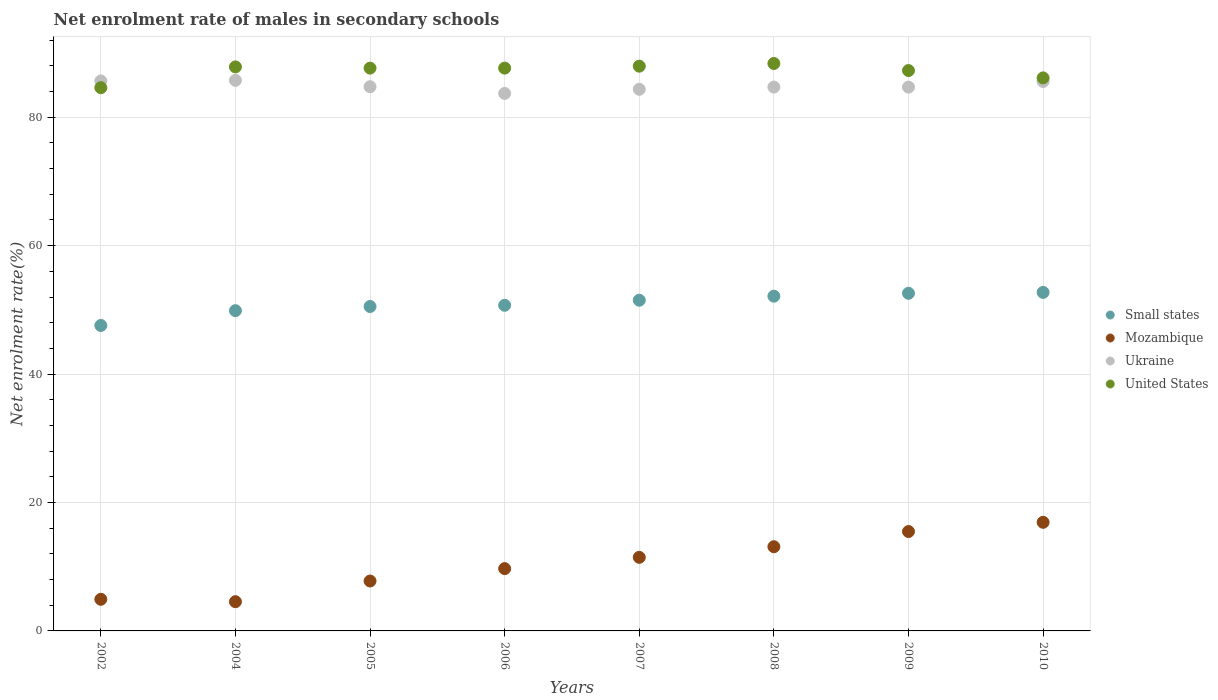How many different coloured dotlines are there?
Give a very brief answer. 4. What is the net enrolment rate of males in secondary schools in Small states in 2004?
Give a very brief answer. 49.88. Across all years, what is the maximum net enrolment rate of males in secondary schools in Mozambique?
Offer a very short reply. 16.92. Across all years, what is the minimum net enrolment rate of males in secondary schools in Mozambique?
Make the answer very short. 4.55. In which year was the net enrolment rate of males in secondary schools in Ukraine minimum?
Give a very brief answer. 2006. What is the total net enrolment rate of males in secondary schools in Ukraine in the graph?
Keep it short and to the point. 679.21. What is the difference between the net enrolment rate of males in secondary schools in Mozambique in 2006 and that in 2008?
Offer a very short reply. -3.41. What is the difference between the net enrolment rate of males in secondary schools in Mozambique in 2002 and the net enrolment rate of males in secondary schools in Ukraine in 2010?
Ensure brevity in your answer.  -80.65. What is the average net enrolment rate of males in secondary schools in United States per year?
Give a very brief answer. 87.19. In the year 2002, what is the difference between the net enrolment rate of males in secondary schools in Ukraine and net enrolment rate of males in secondary schools in Small states?
Offer a terse response. 38.09. What is the ratio of the net enrolment rate of males in secondary schools in Ukraine in 2005 to that in 2006?
Keep it short and to the point. 1.01. What is the difference between the highest and the second highest net enrolment rate of males in secondary schools in Ukraine?
Offer a very short reply. 0.09. What is the difference between the highest and the lowest net enrolment rate of males in secondary schools in Small states?
Give a very brief answer. 5.15. Is the sum of the net enrolment rate of males in secondary schools in United States in 2006 and 2009 greater than the maximum net enrolment rate of males in secondary schools in Mozambique across all years?
Provide a short and direct response. Yes. Is it the case that in every year, the sum of the net enrolment rate of males in secondary schools in Mozambique and net enrolment rate of males in secondary schools in Small states  is greater than the sum of net enrolment rate of males in secondary schools in United States and net enrolment rate of males in secondary schools in Ukraine?
Offer a very short reply. No. Is it the case that in every year, the sum of the net enrolment rate of males in secondary schools in United States and net enrolment rate of males in secondary schools in Ukraine  is greater than the net enrolment rate of males in secondary schools in Mozambique?
Ensure brevity in your answer.  Yes. Is the net enrolment rate of males in secondary schools in United States strictly greater than the net enrolment rate of males in secondary schools in Small states over the years?
Keep it short and to the point. Yes. Is the net enrolment rate of males in secondary schools in Small states strictly less than the net enrolment rate of males in secondary schools in Mozambique over the years?
Provide a short and direct response. No. Does the graph contain any zero values?
Ensure brevity in your answer.  No. Does the graph contain grids?
Your response must be concise. Yes. Where does the legend appear in the graph?
Your answer should be very brief. Center right. How many legend labels are there?
Make the answer very short. 4. What is the title of the graph?
Give a very brief answer. Net enrolment rate of males in secondary schools. What is the label or title of the X-axis?
Your answer should be very brief. Years. What is the label or title of the Y-axis?
Give a very brief answer. Net enrolment rate(%). What is the Net enrolment rate(%) in Small states in 2002?
Provide a short and direct response. 47.57. What is the Net enrolment rate(%) in Mozambique in 2002?
Provide a short and direct response. 4.92. What is the Net enrolment rate(%) of Ukraine in 2002?
Your answer should be compact. 85.66. What is the Net enrolment rate(%) in United States in 2002?
Offer a terse response. 84.61. What is the Net enrolment rate(%) in Small states in 2004?
Offer a terse response. 49.88. What is the Net enrolment rate(%) of Mozambique in 2004?
Your answer should be compact. 4.55. What is the Net enrolment rate(%) in Ukraine in 2004?
Provide a succinct answer. 85.75. What is the Net enrolment rate(%) of United States in 2004?
Ensure brevity in your answer.  87.84. What is the Net enrolment rate(%) in Small states in 2005?
Offer a very short reply. 50.53. What is the Net enrolment rate(%) of Mozambique in 2005?
Provide a succinct answer. 7.77. What is the Net enrolment rate(%) of Ukraine in 2005?
Provide a short and direct response. 84.76. What is the Net enrolment rate(%) of United States in 2005?
Your response must be concise. 87.65. What is the Net enrolment rate(%) of Small states in 2006?
Offer a terse response. 50.71. What is the Net enrolment rate(%) in Mozambique in 2006?
Your answer should be very brief. 9.7. What is the Net enrolment rate(%) of Ukraine in 2006?
Your response must be concise. 83.71. What is the Net enrolment rate(%) in United States in 2006?
Give a very brief answer. 87.65. What is the Net enrolment rate(%) of Small states in 2007?
Your answer should be compact. 51.5. What is the Net enrolment rate(%) in Mozambique in 2007?
Keep it short and to the point. 11.46. What is the Net enrolment rate(%) of Ukraine in 2007?
Keep it short and to the point. 84.36. What is the Net enrolment rate(%) in United States in 2007?
Your answer should be very brief. 87.96. What is the Net enrolment rate(%) in Small states in 2008?
Ensure brevity in your answer.  52.13. What is the Net enrolment rate(%) in Mozambique in 2008?
Your answer should be compact. 13.11. What is the Net enrolment rate(%) in Ukraine in 2008?
Give a very brief answer. 84.7. What is the Net enrolment rate(%) in United States in 2008?
Give a very brief answer. 88.38. What is the Net enrolment rate(%) of Small states in 2009?
Offer a very short reply. 52.59. What is the Net enrolment rate(%) in Mozambique in 2009?
Offer a very short reply. 15.48. What is the Net enrolment rate(%) in Ukraine in 2009?
Your answer should be very brief. 84.7. What is the Net enrolment rate(%) in United States in 2009?
Make the answer very short. 87.27. What is the Net enrolment rate(%) in Small states in 2010?
Offer a very short reply. 52.72. What is the Net enrolment rate(%) in Mozambique in 2010?
Your answer should be compact. 16.92. What is the Net enrolment rate(%) of Ukraine in 2010?
Make the answer very short. 85.57. What is the Net enrolment rate(%) in United States in 2010?
Keep it short and to the point. 86.13. Across all years, what is the maximum Net enrolment rate(%) in Small states?
Your response must be concise. 52.72. Across all years, what is the maximum Net enrolment rate(%) of Mozambique?
Ensure brevity in your answer.  16.92. Across all years, what is the maximum Net enrolment rate(%) of Ukraine?
Your answer should be very brief. 85.75. Across all years, what is the maximum Net enrolment rate(%) of United States?
Your answer should be compact. 88.38. Across all years, what is the minimum Net enrolment rate(%) of Small states?
Provide a short and direct response. 47.57. Across all years, what is the minimum Net enrolment rate(%) in Mozambique?
Provide a short and direct response. 4.55. Across all years, what is the minimum Net enrolment rate(%) in Ukraine?
Offer a very short reply. 83.71. Across all years, what is the minimum Net enrolment rate(%) in United States?
Give a very brief answer. 84.61. What is the total Net enrolment rate(%) of Small states in the graph?
Offer a terse response. 407.64. What is the total Net enrolment rate(%) of Mozambique in the graph?
Keep it short and to the point. 83.92. What is the total Net enrolment rate(%) of Ukraine in the graph?
Offer a terse response. 679.21. What is the total Net enrolment rate(%) in United States in the graph?
Make the answer very short. 697.5. What is the difference between the Net enrolment rate(%) of Small states in 2002 and that in 2004?
Keep it short and to the point. -2.31. What is the difference between the Net enrolment rate(%) of Mozambique in 2002 and that in 2004?
Your answer should be very brief. 0.37. What is the difference between the Net enrolment rate(%) in Ukraine in 2002 and that in 2004?
Your answer should be compact. -0.09. What is the difference between the Net enrolment rate(%) in United States in 2002 and that in 2004?
Offer a terse response. -3.24. What is the difference between the Net enrolment rate(%) in Small states in 2002 and that in 2005?
Your response must be concise. -2.96. What is the difference between the Net enrolment rate(%) in Mozambique in 2002 and that in 2005?
Provide a succinct answer. -2.85. What is the difference between the Net enrolment rate(%) of Ukraine in 2002 and that in 2005?
Your answer should be compact. 0.9. What is the difference between the Net enrolment rate(%) in United States in 2002 and that in 2005?
Your response must be concise. -3.04. What is the difference between the Net enrolment rate(%) in Small states in 2002 and that in 2006?
Offer a terse response. -3.14. What is the difference between the Net enrolment rate(%) of Mozambique in 2002 and that in 2006?
Ensure brevity in your answer.  -4.78. What is the difference between the Net enrolment rate(%) of Ukraine in 2002 and that in 2006?
Offer a very short reply. 1.95. What is the difference between the Net enrolment rate(%) of United States in 2002 and that in 2006?
Make the answer very short. -3.05. What is the difference between the Net enrolment rate(%) of Small states in 2002 and that in 2007?
Provide a succinct answer. -3.93. What is the difference between the Net enrolment rate(%) of Mozambique in 2002 and that in 2007?
Offer a terse response. -6.54. What is the difference between the Net enrolment rate(%) in Ukraine in 2002 and that in 2007?
Offer a terse response. 1.3. What is the difference between the Net enrolment rate(%) in United States in 2002 and that in 2007?
Your answer should be compact. -3.35. What is the difference between the Net enrolment rate(%) in Small states in 2002 and that in 2008?
Ensure brevity in your answer.  -4.56. What is the difference between the Net enrolment rate(%) of Mozambique in 2002 and that in 2008?
Make the answer very short. -8.19. What is the difference between the Net enrolment rate(%) in Ukraine in 2002 and that in 2008?
Make the answer very short. 0.96. What is the difference between the Net enrolment rate(%) in United States in 2002 and that in 2008?
Keep it short and to the point. -3.77. What is the difference between the Net enrolment rate(%) in Small states in 2002 and that in 2009?
Offer a very short reply. -5.02. What is the difference between the Net enrolment rate(%) in Mozambique in 2002 and that in 2009?
Keep it short and to the point. -10.55. What is the difference between the Net enrolment rate(%) of Ukraine in 2002 and that in 2009?
Offer a very short reply. 0.96. What is the difference between the Net enrolment rate(%) of United States in 2002 and that in 2009?
Your response must be concise. -2.67. What is the difference between the Net enrolment rate(%) in Small states in 2002 and that in 2010?
Ensure brevity in your answer.  -5.15. What is the difference between the Net enrolment rate(%) of Mozambique in 2002 and that in 2010?
Provide a short and direct response. -11.99. What is the difference between the Net enrolment rate(%) in Ukraine in 2002 and that in 2010?
Your response must be concise. 0.09. What is the difference between the Net enrolment rate(%) of United States in 2002 and that in 2010?
Keep it short and to the point. -1.53. What is the difference between the Net enrolment rate(%) in Small states in 2004 and that in 2005?
Give a very brief answer. -0.65. What is the difference between the Net enrolment rate(%) in Mozambique in 2004 and that in 2005?
Give a very brief answer. -3.22. What is the difference between the Net enrolment rate(%) in United States in 2004 and that in 2005?
Offer a terse response. 0.19. What is the difference between the Net enrolment rate(%) of Small states in 2004 and that in 2006?
Your response must be concise. -0.83. What is the difference between the Net enrolment rate(%) of Mozambique in 2004 and that in 2006?
Your response must be concise. -5.15. What is the difference between the Net enrolment rate(%) of Ukraine in 2004 and that in 2006?
Offer a very short reply. 2.04. What is the difference between the Net enrolment rate(%) in United States in 2004 and that in 2006?
Give a very brief answer. 0.19. What is the difference between the Net enrolment rate(%) in Small states in 2004 and that in 2007?
Make the answer very short. -1.62. What is the difference between the Net enrolment rate(%) of Mozambique in 2004 and that in 2007?
Keep it short and to the point. -6.91. What is the difference between the Net enrolment rate(%) in Ukraine in 2004 and that in 2007?
Provide a short and direct response. 1.4. What is the difference between the Net enrolment rate(%) in United States in 2004 and that in 2007?
Your answer should be very brief. -0.11. What is the difference between the Net enrolment rate(%) in Small states in 2004 and that in 2008?
Make the answer very short. -2.25. What is the difference between the Net enrolment rate(%) in Mozambique in 2004 and that in 2008?
Offer a terse response. -8.56. What is the difference between the Net enrolment rate(%) in Ukraine in 2004 and that in 2008?
Offer a terse response. 1.05. What is the difference between the Net enrolment rate(%) in United States in 2004 and that in 2008?
Provide a succinct answer. -0.53. What is the difference between the Net enrolment rate(%) in Small states in 2004 and that in 2009?
Ensure brevity in your answer.  -2.71. What is the difference between the Net enrolment rate(%) of Mozambique in 2004 and that in 2009?
Give a very brief answer. -10.93. What is the difference between the Net enrolment rate(%) of Ukraine in 2004 and that in 2009?
Provide a succinct answer. 1.06. What is the difference between the Net enrolment rate(%) of United States in 2004 and that in 2009?
Make the answer very short. 0.57. What is the difference between the Net enrolment rate(%) in Small states in 2004 and that in 2010?
Keep it short and to the point. -2.84. What is the difference between the Net enrolment rate(%) of Mozambique in 2004 and that in 2010?
Ensure brevity in your answer.  -12.36. What is the difference between the Net enrolment rate(%) in Ukraine in 2004 and that in 2010?
Your answer should be very brief. 0.18. What is the difference between the Net enrolment rate(%) of United States in 2004 and that in 2010?
Your answer should be very brief. 1.71. What is the difference between the Net enrolment rate(%) in Small states in 2005 and that in 2006?
Your response must be concise. -0.19. What is the difference between the Net enrolment rate(%) in Mozambique in 2005 and that in 2006?
Make the answer very short. -1.93. What is the difference between the Net enrolment rate(%) of Ukraine in 2005 and that in 2006?
Your answer should be very brief. 1.05. What is the difference between the Net enrolment rate(%) of United States in 2005 and that in 2006?
Your answer should be very brief. -0. What is the difference between the Net enrolment rate(%) in Small states in 2005 and that in 2007?
Keep it short and to the point. -0.98. What is the difference between the Net enrolment rate(%) in Mozambique in 2005 and that in 2007?
Give a very brief answer. -3.69. What is the difference between the Net enrolment rate(%) in Ukraine in 2005 and that in 2007?
Offer a very short reply. 0.4. What is the difference between the Net enrolment rate(%) in United States in 2005 and that in 2007?
Keep it short and to the point. -0.3. What is the difference between the Net enrolment rate(%) in Small states in 2005 and that in 2008?
Your answer should be very brief. -1.61. What is the difference between the Net enrolment rate(%) in Mozambique in 2005 and that in 2008?
Your response must be concise. -5.34. What is the difference between the Net enrolment rate(%) of Ukraine in 2005 and that in 2008?
Keep it short and to the point. 0.06. What is the difference between the Net enrolment rate(%) in United States in 2005 and that in 2008?
Offer a terse response. -0.72. What is the difference between the Net enrolment rate(%) in Small states in 2005 and that in 2009?
Your answer should be very brief. -2.06. What is the difference between the Net enrolment rate(%) of Mozambique in 2005 and that in 2009?
Offer a very short reply. -7.71. What is the difference between the Net enrolment rate(%) in Ukraine in 2005 and that in 2009?
Your answer should be compact. 0.06. What is the difference between the Net enrolment rate(%) of United States in 2005 and that in 2009?
Your answer should be compact. 0.38. What is the difference between the Net enrolment rate(%) of Small states in 2005 and that in 2010?
Provide a short and direct response. -2.2. What is the difference between the Net enrolment rate(%) in Mozambique in 2005 and that in 2010?
Your answer should be compact. -9.14. What is the difference between the Net enrolment rate(%) in Ukraine in 2005 and that in 2010?
Your answer should be compact. -0.81. What is the difference between the Net enrolment rate(%) of United States in 2005 and that in 2010?
Ensure brevity in your answer.  1.52. What is the difference between the Net enrolment rate(%) of Small states in 2006 and that in 2007?
Provide a short and direct response. -0.79. What is the difference between the Net enrolment rate(%) in Mozambique in 2006 and that in 2007?
Offer a very short reply. -1.76. What is the difference between the Net enrolment rate(%) in Ukraine in 2006 and that in 2007?
Give a very brief answer. -0.64. What is the difference between the Net enrolment rate(%) in United States in 2006 and that in 2007?
Provide a short and direct response. -0.3. What is the difference between the Net enrolment rate(%) in Small states in 2006 and that in 2008?
Your answer should be compact. -1.42. What is the difference between the Net enrolment rate(%) of Mozambique in 2006 and that in 2008?
Offer a very short reply. -3.41. What is the difference between the Net enrolment rate(%) of Ukraine in 2006 and that in 2008?
Keep it short and to the point. -0.99. What is the difference between the Net enrolment rate(%) in United States in 2006 and that in 2008?
Offer a terse response. -0.72. What is the difference between the Net enrolment rate(%) in Small states in 2006 and that in 2009?
Offer a very short reply. -1.87. What is the difference between the Net enrolment rate(%) of Mozambique in 2006 and that in 2009?
Give a very brief answer. -5.78. What is the difference between the Net enrolment rate(%) of Ukraine in 2006 and that in 2009?
Make the answer very short. -0.98. What is the difference between the Net enrolment rate(%) of United States in 2006 and that in 2009?
Keep it short and to the point. 0.38. What is the difference between the Net enrolment rate(%) of Small states in 2006 and that in 2010?
Ensure brevity in your answer.  -2.01. What is the difference between the Net enrolment rate(%) in Mozambique in 2006 and that in 2010?
Offer a very short reply. -7.21. What is the difference between the Net enrolment rate(%) of Ukraine in 2006 and that in 2010?
Your answer should be compact. -1.86. What is the difference between the Net enrolment rate(%) in United States in 2006 and that in 2010?
Provide a short and direct response. 1.52. What is the difference between the Net enrolment rate(%) of Small states in 2007 and that in 2008?
Offer a terse response. -0.63. What is the difference between the Net enrolment rate(%) of Mozambique in 2007 and that in 2008?
Your answer should be compact. -1.65. What is the difference between the Net enrolment rate(%) of Ukraine in 2007 and that in 2008?
Provide a succinct answer. -0.35. What is the difference between the Net enrolment rate(%) of United States in 2007 and that in 2008?
Make the answer very short. -0.42. What is the difference between the Net enrolment rate(%) in Small states in 2007 and that in 2009?
Provide a short and direct response. -1.08. What is the difference between the Net enrolment rate(%) of Mozambique in 2007 and that in 2009?
Your answer should be compact. -4.02. What is the difference between the Net enrolment rate(%) in Ukraine in 2007 and that in 2009?
Ensure brevity in your answer.  -0.34. What is the difference between the Net enrolment rate(%) of United States in 2007 and that in 2009?
Offer a terse response. 0.68. What is the difference between the Net enrolment rate(%) in Small states in 2007 and that in 2010?
Provide a short and direct response. -1.22. What is the difference between the Net enrolment rate(%) of Mozambique in 2007 and that in 2010?
Make the answer very short. -5.45. What is the difference between the Net enrolment rate(%) in Ukraine in 2007 and that in 2010?
Make the answer very short. -1.22. What is the difference between the Net enrolment rate(%) in United States in 2007 and that in 2010?
Your answer should be very brief. 1.82. What is the difference between the Net enrolment rate(%) of Small states in 2008 and that in 2009?
Your response must be concise. -0.45. What is the difference between the Net enrolment rate(%) in Mozambique in 2008 and that in 2009?
Provide a short and direct response. -2.36. What is the difference between the Net enrolment rate(%) of Ukraine in 2008 and that in 2009?
Your answer should be compact. 0.01. What is the difference between the Net enrolment rate(%) of United States in 2008 and that in 2009?
Your answer should be compact. 1.1. What is the difference between the Net enrolment rate(%) in Small states in 2008 and that in 2010?
Your answer should be very brief. -0.59. What is the difference between the Net enrolment rate(%) in Mozambique in 2008 and that in 2010?
Ensure brevity in your answer.  -3.8. What is the difference between the Net enrolment rate(%) in Ukraine in 2008 and that in 2010?
Provide a short and direct response. -0.87. What is the difference between the Net enrolment rate(%) in United States in 2008 and that in 2010?
Make the answer very short. 2.24. What is the difference between the Net enrolment rate(%) in Small states in 2009 and that in 2010?
Make the answer very short. -0.14. What is the difference between the Net enrolment rate(%) of Mozambique in 2009 and that in 2010?
Your answer should be compact. -1.44. What is the difference between the Net enrolment rate(%) in Ukraine in 2009 and that in 2010?
Offer a very short reply. -0.88. What is the difference between the Net enrolment rate(%) of United States in 2009 and that in 2010?
Your answer should be compact. 1.14. What is the difference between the Net enrolment rate(%) of Small states in 2002 and the Net enrolment rate(%) of Mozambique in 2004?
Provide a short and direct response. 43.02. What is the difference between the Net enrolment rate(%) in Small states in 2002 and the Net enrolment rate(%) in Ukraine in 2004?
Ensure brevity in your answer.  -38.18. What is the difference between the Net enrolment rate(%) of Small states in 2002 and the Net enrolment rate(%) of United States in 2004?
Provide a succinct answer. -40.27. What is the difference between the Net enrolment rate(%) in Mozambique in 2002 and the Net enrolment rate(%) in Ukraine in 2004?
Provide a succinct answer. -80.83. What is the difference between the Net enrolment rate(%) in Mozambique in 2002 and the Net enrolment rate(%) in United States in 2004?
Give a very brief answer. -82.92. What is the difference between the Net enrolment rate(%) in Ukraine in 2002 and the Net enrolment rate(%) in United States in 2004?
Provide a short and direct response. -2.19. What is the difference between the Net enrolment rate(%) of Small states in 2002 and the Net enrolment rate(%) of Mozambique in 2005?
Keep it short and to the point. 39.8. What is the difference between the Net enrolment rate(%) in Small states in 2002 and the Net enrolment rate(%) in Ukraine in 2005?
Offer a very short reply. -37.19. What is the difference between the Net enrolment rate(%) in Small states in 2002 and the Net enrolment rate(%) in United States in 2005?
Your response must be concise. -40.08. What is the difference between the Net enrolment rate(%) of Mozambique in 2002 and the Net enrolment rate(%) of Ukraine in 2005?
Offer a terse response. -79.83. What is the difference between the Net enrolment rate(%) of Mozambique in 2002 and the Net enrolment rate(%) of United States in 2005?
Your response must be concise. -82.73. What is the difference between the Net enrolment rate(%) of Ukraine in 2002 and the Net enrolment rate(%) of United States in 2005?
Offer a very short reply. -1.99. What is the difference between the Net enrolment rate(%) of Small states in 2002 and the Net enrolment rate(%) of Mozambique in 2006?
Ensure brevity in your answer.  37.87. What is the difference between the Net enrolment rate(%) of Small states in 2002 and the Net enrolment rate(%) of Ukraine in 2006?
Your answer should be compact. -36.14. What is the difference between the Net enrolment rate(%) of Small states in 2002 and the Net enrolment rate(%) of United States in 2006?
Ensure brevity in your answer.  -40.08. What is the difference between the Net enrolment rate(%) of Mozambique in 2002 and the Net enrolment rate(%) of Ukraine in 2006?
Offer a very short reply. -78.79. What is the difference between the Net enrolment rate(%) in Mozambique in 2002 and the Net enrolment rate(%) in United States in 2006?
Your response must be concise. -82.73. What is the difference between the Net enrolment rate(%) of Ukraine in 2002 and the Net enrolment rate(%) of United States in 2006?
Your answer should be compact. -2. What is the difference between the Net enrolment rate(%) in Small states in 2002 and the Net enrolment rate(%) in Mozambique in 2007?
Ensure brevity in your answer.  36.11. What is the difference between the Net enrolment rate(%) of Small states in 2002 and the Net enrolment rate(%) of Ukraine in 2007?
Keep it short and to the point. -36.78. What is the difference between the Net enrolment rate(%) of Small states in 2002 and the Net enrolment rate(%) of United States in 2007?
Your response must be concise. -40.39. What is the difference between the Net enrolment rate(%) of Mozambique in 2002 and the Net enrolment rate(%) of Ukraine in 2007?
Offer a terse response. -79.43. What is the difference between the Net enrolment rate(%) of Mozambique in 2002 and the Net enrolment rate(%) of United States in 2007?
Provide a succinct answer. -83.03. What is the difference between the Net enrolment rate(%) in Ukraine in 2002 and the Net enrolment rate(%) in United States in 2007?
Offer a terse response. -2.3. What is the difference between the Net enrolment rate(%) in Small states in 2002 and the Net enrolment rate(%) in Mozambique in 2008?
Offer a terse response. 34.46. What is the difference between the Net enrolment rate(%) of Small states in 2002 and the Net enrolment rate(%) of Ukraine in 2008?
Keep it short and to the point. -37.13. What is the difference between the Net enrolment rate(%) of Small states in 2002 and the Net enrolment rate(%) of United States in 2008?
Your response must be concise. -40.8. What is the difference between the Net enrolment rate(%) in Mozambique in 2002 and the Net enrolment rate(%) in Ukraine in 2008?
Your answer should be compact. -79.78. What is the difference between the Net enrolment rate(%) of Mozambique in 2002 and the Net enrolment rate(%) of United States in 2008?
Your response must be concise. -83.45. What is the difference between the Net enrolment rate(%) in Ukraine in 2002 and the Net enrolment rate(%) in United States in 2008?
Your response must be concise. -2.72. What is the difference between the Net enrolment rate(%) in Small states in 2002 and the Net enrolment rate(%) in Mozambique in 2009?
Give a very brief answer. 32.09. What is the difference between the Net enrolment rate(%) of Small states in 2002 and the Net enrolment rate(%) of Ukraine in 2009?
Provide a short and direct response. -37.12. What is the difference between the Net enrolment rate(%) in Small states in 2002 and the Net enrolment rate(%) in United States in 2009?
Your answer should be compact. -39.7. What is the difference between the Net enrolment rate(%) in Mozambique in 2002 and the Net enrolment rate(%) in Ukraine in 2009?
Provide a short and direct response. -79.77. What is the difference between the Net enrolment rate(%) of Mozambique in 2002 and the Net enrolment rate(%) of United States in 2009?
Keep it short and to the point. -82.35. What is the difference between the Net enrolment rate(%) in Ukraine in 2002 and the Net enrolment rate(%) in United States in 2009?
Provide a short and direct response. -1.62. What is the difference between the Net enrolment rate(%) in Small states in 2002 and the Net enrolment rate(%) in Mozambique in 2010?
Your answer should be compact. 30.66. What is the difference between the Net enrolment rate(%) of Small states in 2002 and the Net enrolment rate(%) of Ukraine in 2010?
Give a very brief answer. -38. What is the difference between the Net enrolment rate(%) of Small states in 2002 and the Net enrolment rate(%) of United States in 2010?
Your answer should be very brief. -38.56. What is the difference between the Net enrolment rate(%) in Mozambique in 2002 and the Net enrolment rate(%) in Ukraine in 2010?
Keep it short and to the point. -80.65. What is the difference between the Net enrolment rate(%) of Mozambique in 2002 and the Net enrolment rate(%) of United States in 2010?
Provide a succinct answer. -81.21. What is the difference between the Net enrolment rate(%) in Ukraine in 2002 and the Net enrolment rate(%) in United States in 2010?
Make the answer very short. -0.48. What is the difference between the Net enrolment rate(%) in Small states in 2004 and the Net enrolment rate(%) in Mozambique in 2005?
Provide a succinct answer. 42.11. What is the difference between the Net enrolment rate(%) of Small states in 2004 and the Net enrolment rate(%) of Ukraine in 2005?
Offer a terse response. -34.88. What is the difference between the Net enrolment rate(%) in Small states in 2004 and the Net enrolment rate(%) in United States in 2005?
Provide a succinct answer. -37.77. What is the difference between the Net enrolment rate(%) of Mozambique in 2004 and the Net enrolment rate(%) of Ukraine in 2005?
Provide a succinct answer. -80.21. What is the difference between the Net enrolment rate(%) in Mozambique in 2004 and the Net enrolment rate(%) in United States in 2005?
Your response must be concise. -83.1. What is the difference between the Net enrolment rate(%) in Ukraine in 2004 and the Net enrolment rate(%) in United States in 2005?
Offer a very short reply. -1.9. What is the difference between the Net enrolment rate(%) in Small states in 2004 and the Net enrolment rate(%) in Mozambique in 2006?
Keep it short and to the point. 40.18. What is the difference between the Net enrolment rate(%) in Small states in 2004 and the Net enrolment rate(%) in Ukraine in 2006?
Provide a succinct answer. -33.83. What is the difference between the Net enrolment rate(%) in Small states in 2004 and the Net enrolment rate(%) in United States in 2006?
Your response must be concise. -37.77. What is the difference between the Net enrolment rate(%) of Mozambique in 2004 and the Net enrolment rate(%) of Ukraine in 2006?
Your response must be concise. -79.16. What is the difference between the Net enrolment rate(%) of Mozambique in 2004 and the Net enrolment rate(%) of United States in 2006?
Make the answer very short. -83.1. What is the difference between the Net enrolment rate(%) of Ukraine in 2004 and the Net enrolment rate(%) of United States in 2006?
Your response must be concise. -1.9. What is the difference between the Net enrolment rate(%) in Small states in 2004 and the Net enrolment rate(%) in Mozambique in 2007?
Ensure brevity in your answer.  38.42. What is the difference between the Net enrolment rate(%) in Small states in 2004 and the Net enrolment rate(%) in Ukraine in 2007?
Your response must be concise. -34.48. What is the difference between the Net enrolment rate(%) in Small states in 2004 and the Net enrolment rate(%) in United States in 2007?
Provide a short and direct response. -38.08. What is the difference between the Net enrolment rate(%) in Mozambique in 2004 and the Net enrolment rate(%) in Ukraine in 2007?
Offer a very short reply. -79.8. What is the difference between the Net enrolment rate(%) of Mozambique in 2004 and the Net enrolment rate(%) of United States in 2007?
Offer a terse response. -83.41. What is the difference between the Net enrolment rate(%) of Ukraine in 2004 and the Net enrolment rate(%) of United States in 2007?
Provide a succinct answer. -2.2. What is the difference between the Net enrolment rate(%) in Small states in 2004 and the Net enrolment rate(%) in Mozambique in 2008?
Your answer should be compact. 36.77. What is the difference between the Net enrolment rate(%) in Small states in 2004 and the Net enrolment rate(%) in Ukraine in 2008?
Ensure brevity in your answer.  -34.82. What is the difference between the Net enrolment rate(%) of Small states in 2004 and the Net enrolment rate(%) of United States in 2008?
Give a very brief answer. -38.5. What is the difference between the Net enrolment rate(%) in Mozambique in 2004 and the Net enrolment rate(%) in Ukraine in 2008?
Your answer should be compact. -80.15. What is the difference between the Net enrolment rate(%) of Mozambique in 2004 and the Net enrolment rate(%) of United States in 2008?
Provide a succinct answer. -83.82. What is the difference between the Net enrolment rate(%) in Ukraine in 2004 and the Net enrolment rate(%) in United States in 2008?
Provide a succinct answer. -2.62. What is the difference between the Net enrolment rate(%) of Small states in 2004 and the Net enrolment rate(%) of Mozambique in 2009?
Offer a terse response. 34.4. What is the difference between the Net enrolment rate(%) in Small states in 2004 and the Net enrolment rate(%) in Ukraine in 2009?
Provide a succinct answer. -34.82. What is the difference between the Net enrolment rate(%) of Small states in 2004 and the Net enrolment rate(%) of United States in 2009?
Your answer should be compact. -37.39. What is the difference between the Net enrolment rate(%) of Mozambique in 2004 and the Net enrolment rate(%) of Ukraine in 2009?
Offer a very short reply. -80.14. What is the difference between the Net enrolment rate(%) in Mozambique in 2004 and the Net enrolment rate(%) in United States in 2009?
Provide a succinct answer. -82.72. What is the difference between the Net enrolment rate(%) of Ukraine in 2004 and the Net enrolment rate(%) of United States in 2009?
Provide a succinct answer. -1.52. What is the difference between the Net enrolment rate(%) in Small states in 2004 and the Net enrolment rate(%) in Mozambique in 2010?
Your answer should be very brief. 32.96. What is the difference between the Net enrolment rate(%) in Small states in 2004 and the Net enrolment rate(%) in Ukraine in 2010?
Offer a very short reply. -35.69. What is the difference between the Net enrolment rate(%) in Small states in 2004 and the Net enrolment rate(%) in United States in 2010?
Your answer should be compact. -36.25. What is the difference between the Net enrolment rate(%) in Mozambique in 2004 and the Net enrolment rate(%) in Ukraine in 2010?
Your answer should be very brief. -81.02. What is the difference between the Net enrolment rate(%) in Mozambique in 2004 and the Net enrolment rate(%) in United States in 2010?
Give a very brief answer. -81.58. What is the difference between the Net enrolment rate(%) in Ukraine in 2004 and the Net enrolment rate(%) in United States in 2010?
Provide a short and direct response. -0.38. What is the difference between the Net enrolment rate(%) of Small states in 2005 and the Net enrolment rate(%) of Mozambique in 2006?
Give a very brief answer. 40.82. What is the difference between the Net enrolment rate(%) of Small states in 2005 and the Net enrolment rate(%) of Ukraine in 2006?
Offer a terse response. -33.19. What is the difference between the Net enrolment rate(%) of Small states in 2005 and the Net enrolment rate(%) of United States in 2006?
Offer a terse response. -37.13. What is the difference between the Net enrolment rate(%) in Mozambique in 2005 and the Net enrolment rate(%) in Ukraine in 2006?
Provide a succinct answer. -75.94. What is the difference between the Net enrolment rate(%) of Mozambique in 2005 and the Net enrolment rate(%) of United States in 2006?
Ensure brevity in your answer.  -79.88. What is the difference between the Net enrolment rate(%) of Ukraine in 2005 and the Net enrolment rate(%) of United States in 2006?
Your answer should be very brief. -2.89. What is the difference between the Net enrolment rate(%) of Small states in 2005 and the Net enrolment rate(%) of Mozambique in 2007?
Ensure brevity in your answer.  39.07. What is the difference between the Net enrolment rate(%) of Small states in 2005 and the Net enrolment rate(%) of Ukraine in 2007?
Give a very brief answer. -33.83. What is the difference between the Net enrolment rate(%) in Small states in 2005 and the Net enrolment rate(%) in United States in 2007?
Give a very brief answer. -37.43. What is the difference between the Net enrolment rate(%) of Mozambique in 2005 and the Net enrolment rate(%) of Ukraine in 2007?
Ensure brevity in your answer.  -76.58. What is the difference between the Net enrolment rate(%) of Mozambique in 2005 and the Net enrolment rate(%) of United States in 2007?
Offer a very short reply. -80.18. What is the difference between the Net enrolment rate(%) in Ukraine in 2005 and the Net enrolment rate(%) in United States in 2007?
Offer a very short reply. -3.2. What is the difference between the Net enrolment rate(%) of Small states in 2005 and the Net enrolment rate(%) of Mozambique in 2008?
Ensure brevity in your answer.  37.41. What is the difference between the Net enrolment rate(%) of Small states in 2005 and the Net enrolment rate(%) of Ukraine in 2008?
Offer a terse response. -34.17. What is the difference between the Net enrolment rate(%) of Small states in 2005 and the Net enrolment rate(%) of United States in 2008?
Keep it short and to the point. -37.85. What is the difference between the Net enrolment rate(%) in Mozambique in 2005 and the Net enrolment rate(%) in Ukraine in 2008?
Keep it short and to the point. -76.93. What is the difference between the Net enrolment rate(%) in Mozambique in 2005 and the Net enrolment rate(%) in United States in 2008?
Keep it short and to the point. -80.6. What is the difference between the Net enrolment rate(%) in Ukraine in 2005 and the Net enrolment rate(%) in United States in 2008?
Make the answer very short. -3.62. What is the difference between the Net enrolment rate(%) in Small states in 2005 and the Net enrolment rate(%) in Mozambique in 2009?
Ensure brevity in your answer.  35.05. What is the difference between the Net enrolment rate(%) of Small states in 2005 and the Net enrolment rate(%) of Ukraine in 2009?
Offer a terse response. -34.17. What is the difference between the Net enrolment rate(%) of Small states in 2005 and the Net enrolment rate(%) of United States in 2009?
Make the answer very short. -36.75. What is the difference between the Net enrolment rate(%) in Mozambique in 2005 and the Net enrolment rate(%) in Ukraine in 2009?
Make the answer very short. -76.92. What is the difference between the Net enrolment rate(%) in Mozambique in 2005 and the Net enrolment rate(%) in United States in 2009?
Offer a terse response. -79.5. What is the difference between the Net enrolment rate(%) of Ukraine in 2005 and the Net enrolment rate(%) of United States in 2009?
Keep it short and to the point. -2.52. What is the difference between the Net enrolment rate(%) in Small states in 2005 and the Net enrolment rate(%) in Mozambique in 2010?
Provide a short and direct response. 33.61. What is the difference between the Net enrolment rate(%) in Small states in 2005 and the Net enrolment rate(%) in Ukraine in 2010?
Offer a terse response. -35.04. What is the difference between the Net enrolment rate(%) of Small states in 2005 and the Net enrolment rate(%) of United States in 2010?
Give a very brief answer. -35.61. What is the difference between the Net enrolment rate(%) in Mozambique in 2005 and the Net enrolment rate(%) in Ukraine in 2010?
Offer a very short reply. -77.8. What is the difference between the Net enrolment rate(%) of Mozambique in 2005 and the Net enrolment rate(%) of United States in 2010?
Provide a short and direct response. -78.36. What is the difference between the Net enrolment rate(%) of Ukraine in 2005 and the Net enrolment rate(%) of United States in 2010?
Ensure brevity in your answer.  -1.37. What is the difference between the Net enrolment rate(%) of Small states in 2006 and the Net enrolment rate(%) of Mozambique in 2007?
Your response must be concise. 39.25. What is the difference between the Net enrolment rate(%) of Small states in 2006 and the Net enrolment rate(%) of Ukraine in 2007?
Ensure brevity in your answer.  -33.64. What is the difference between the Net enrolment rate(%) in Small states in 2006 and the Net enrolment rate(%) in United States in 2007?
Make the answer very short. -37.24. What is the difference between the Net enrolment rate(%) of Mozambique in 2006 and the Net enrolment rate(%) of Ukraine in 2007?
Offer a very short reply. -74.65. What is the difference between the Net enrolment rate(%) in Mozambique in 2006 and the Net enrolment rate(%) in United States in 2007?
Provide a short and direct response. -78.25. What is the difference between the Net enrolment rate(%) in Ukraine in 2006 and the Net enrolment rate(%) in United States in 2007?
Give a very brief answer. -4.24. What is the difference between the Net enrolment rate(%) of Small states in 2006 and the Net enrolment rate(%) of Mozambique in 2008?
Your answer should be compact. 37.6. What is the difference between the Net enrolment rate(%) in Small states in 2006 and the Net enrolment rate(%) in Ukraine in 2008?
Make the answer very short. -33.99. What is the difference between the Net enrolment rate(%) in Small states in 2006 and the Net enrolment rate(%) in United States in 2008?
Keep it short and to the point. -37.66. What is the difference between the Net enrolment rate(%) in Mozambique in 2006 and the Net enrolment rate(%) in Ukraine in 2008?
Make the answer very short. -75. What is the difference between the Net enrolment rate(%) in Mozambique in 2006 and the Net enrolment rate(%) in United States in 2008?
Your answer should be compact. -78.67. What is the difference between the Net enrolment rate(%) in Ukraine in 2006 and the Net enrolment rate(%) in United States in 2008?
Provide a short and direct response. -4.66. What is the difference between the Net enrolment rate(%) in Small states in 2006 and the Net enrolment rate(%) in Mozambique in 2009?
Give a very brief answer. 35.23. What is the difference between the Net enrolment rate(%) in Small states in 2006 and the Net enrolment rate(%) in Ukraine in 2009?
Keep it short and to the point. -33.98. What is the difference between the Net enrolment rate(%) in Small states in 2006 and the Net enrolment rate(%) in United States in 2009?
Offer a terse response. -36.56. What is the difference between the Net enrolment rate(%) of Mozambique in 2006 and the Net enrolment rate(%) of Ukraine in 2009?
Offer a terse response. -74.99. What is the difference between the Net enrolment rate(%) of Mozambique in 2006 and the Net enrolment rate(%) of United States in 2009?
Provide a short and direct response. -77.57. What is the difference between the Net enrolment rate(%) in Ukraine in 2006 and the Net enrolment rate(%) in United States in 2009?
Make the answer very short. -3.56. What is the difference between the Net enrolment rate(%) of Small states in 2006 and the Net enrolment rate(%) of Mozambique in 2010?
Ensure brevity in your answer.  33.8. What is the difference between the Net enrolment rate(%) of Small states in 2006 and the Net enrolment rate(%) of Ukraine in 2010?
Your answer should be very brief. -34.86. What is the difference between the Net enrolment rate(%) in Small states in 2006 and the Net enrolment rate(%) in United States in 2010?
Ensure brevity in your answer.  -35.42. What is the difference between the Net enrolment rate(%) in Mozambique in 2006 and the Net enrolment rate(%) in Ukraine in 2010?
Give a very brief answer. -75.87. What is the difference between the Net enrolment rate(%) of Mozambique in 2006 and the Net enrolment rate(%) of United States in 2010?
Keep it short and to the point. -76.43. What is the difference between the Net enrolment rate(%) in Ukraine in 2006 and the Net enrolment rate(%) in United States in 2010?
Ensure brevity in your answer.  -2.42. What is the difference between the Net enrolment rate(%) in Small states in 2007 and the Net enrolment rate(%) in Mozambique in 2008?
Offer a very short reply. 38.39. What is the difference between the Net enrolment rate(%) of Small states in 2007 and the Net enrolment rate(%) of Ukraine in 2008?
Your answer should be compact. -33.2. What is the difference between the Net enrolment rate(%) in Small states in 2007 and the Net enrolment rate(%) in United States in 2008?
Offer a very short reply. -36.87. What is the difference between the Net enrolment rate(%) in Mozambique in 2007 and the Net enrolment rate(%) in Ukraine in 2008?
Provide a succinct answer. -73.24. What is the difference between the Net enrolment rate(%) of Mozambique in 2007 and the Net enrolment rate(%) of United States in 2008?
Offer a very short reply. -76.91. What is the difference between the Net enrolment rate(%) of Ukraine in 2007 and the Net enrolment rate(%) of United States in 2008?
Provide a succinct answer. -4.02. What is the difference between the Net enrolment rate(%) in Small states in 2007 and the Net enrolment rate(%) in Mozambique in 2009?
Provide a short and direct response. 36.02. What is the difference between the Net enrolment rate(%) of Small states in 2007 and the Net enrolment rate(%) of Ukraine in 2009?
Provide a succinct answer. -33.19. What is the difference between the Net enrolment rate(%) of Small states in 2007 and the Net enrolment rate(%) of United States in 2009?
Offer a terse response. -35.77. What is the difference between the Net enrolment rate(%) in Mozambique in 2007 and the Net enrolment rate(%) in Ukraine in 2009?
Offer a very short reply. -73.23. What is the difference between the Net enrolment rate(%) of Mozambique in 2007 and the Net enrolment rate(%) of United States in 2009?
Ensure brevity in your answer.  -75.81. What is the difference between the Net enrolment rate(%) in Ukraine in 2007 and the Net enrolment rate(%) in United States in 2009?
Offer a terse response. -2.92. What is the difference between the Net enrolment rate(%) of Small states in 2007 and the Net enrolment rate(%) of Mozambique in 2010?
Your answer should be compact. 34.59. What is the difference between the Net enrolment rate(%) in Small states in 2007 and the Net enrolment rate(%) in Ukraine in 2010?
Offer a terse response. -34.07. What is the difference between the Net enrolment rate(%) of Small states in 2007 and the Net enrolment rate(%) of United States in 2010?
Offer a very short reply. -34.63. What is the difference between the Net enrolment rate(%) in Mozambique in 2007 and the Net enrolment rate(%) in Ukraine in 2010?
Your answer should be very brief. -74.11. What is the difference between the Net enrolment rate(%) in Mozambique in 2007 and the Net enrolment rate(%) in United States in 2010?
Make the answer very short. -74.67. What is the difference between the Net enrolment rate(%) in Ukraine in 2007 and the Net enrolment rate(%) in United States in 2010?
Provide a succinct answer. -1.78. What is the difference between the Net enrolment rate(%) in Small states in 2008 and the Net enrolment rate(%) in Mozambique in 2009?
Give a very brief answer. 36.65. What is the difference between the Net enrolment rate(%) of Small states in 2008 and the Net enrolment rate(%) of Ukraine in 2009?
Ensure brevity in your answer.  -32.56. What is the difference between the Net enrolment rate(%) of Small states in 2008 and the Net enrolment rate(%) of United States in 2009?
Provide a succinct answer. -35.14. What is the difference between the Net enrolment rate(%) in Mozambique in 2008 and the Net enrolment rate(%) in Ukraine in 2009?
Your answer should be very brief. -71.58. What is the difference between the Net enrolment rate(%) in Mozambique in 2008 and the Net enrolment rate(%) in United States in 2009?
Offer a terse response. -74.16. What is the difference between the Net enrolment rate(%) in Ukraine in 2008 and the Net enrolment rate(%) in United States in 2009?
Give a very brief answer. -2.57. What is the difference between the Net enrolment rate(%) of Small states in 2008 and the Net enrolment rate(%) of Mozambique in 2010?
Ensure brevity in your answer.  35.22. What is the difference between the Net enrolment rate(%) of Small states in 2008 and the Net enrolment rate(%) of Ukraine in 2010?
Keep it short and to the point. -33.44. What is the difference between the Net enrolment rate(%) of Small states in 2008 and the Net enrolment rate(%) of United States in 2010?
Offer a terse response. -34. What is the difference between the Net enrolment rate(%) in Mozambique in 2008 and the Net enrolment rate(%) in Ukraine in 2010?
Make the answer very short. -72.46. What is the difference between the Net enrolment rate(%) of Mozambique in 2008 and the Net enrolment rate(%) of United States in 2010?
Provide a short and direct response. -73.02. What is the difference between the Net enrolment rate(%) of Ukraine in 2008 and the Net enrolment rate(%) of United States in 2010?
Your answer should be very brief. -1.43. What is the difference between the Net enrolment rate(%) of Small states in 2009 and the Net enrolment rate(%) of Mozambique in 2010?
Make the answer very short. 35.67. What is the difference between the Net enrolment rate(%) in Small states in 2009 and the Net enrolment rate(%) in Ukraine in 2010?
Keep it short and to the point. -32.99. What is the difference between the Net enrolment rate(%) of Small states in 2009 and the Net enrolment rate(%) of United States in 2010?
Keep it short and to the point. -33.55. What is the difference between the Net enrolment rate(%) of Mozambique in 2009 and the Net enrolment rate(%) of Ukraine in 2010?
Your answer should be very brief. -70.09. What is the difference between the Net enrolment rate(%) in Mozambique in 2009 and the Net enrolment rate(%) in United States in 2010?
Provide a short and direct response. -70.65. What is the difference between the Net enrolment rate(%) in Ukraine in 2009 and the Net enrolment rate(%) in United States in 2010?
Provide a succinct answer. -1.44. What is the average Net enrolment rate(%) in Small states per year?
Provide a short and direct response. 50.96. What is the average Net enrolment rate(%) of Mozambique per year?
Provide a succinct answer. 10.49. What is the average Net enrolment rate(%) in Ukraine per year?
Provide a short and direct response. 84.9. What is the average Net enrolment rate(%) in United States per year?
Ensure brevity in your answer.  87.19. In the year 2002, what is the difference between the Net enrolment rate(%) of Small states and Net enrolment rate(%) of Mozambique?
Provide a short and direct response. 42.65. In the year 2002, what is the difference between the Net enrolment rate(%) in Small states and Net enrolment rate(%) in Ukraine?
Give a very brief answer. -38.09. In the year 2002, what is the difference between the Net enrolment rate(%) of Small states and Net enrolment rate(%) of United States?
Your answer should be very brief. -37.04. In the year 2002, what is the difference between the Net enrolment rate(%) in Mozambique and Net enrolment rate(%) in Ukraine?
Your answer should be very brief. -80.73. In the year 2002, what is the difference between the Net enrolment rate(%) of Mozambique and Net enrolment rate(%) of United States?
Keep it short and to the point. -79.68. In the year 2002, what is the difference between the Net enrolment rate(%) in Ukraine and Net enrolment rate(%) in United States?
Your answer should be very brief. 1.05. In the year 2004, what is the difference between the Net enrolment rate(%) in Small states and Net enrolment rate(%) in Mozambique?
Your answer should be compact. 45.33. In the year 2004, what is the difference between the Net enrolment rate(%) of Small states and Net enrolment rate(%) of Ukraine?
Offer a terse response. -35.87. In the year 2004, what is the difference between the Net enrolment rate(%) of Small states and Net enrolment rate(%) of United States?
Offer a terse response. -37.96. In the year 2004, what is the difference between the Net enrolment rate(%) in Mozambique and Net enrolment rate(%) in Ukraine?
Your answer should be very brief. -81.2. In the year 2004, what is the difference between the Net enrolment rate(%) of Mozambique and Net enrolment rate(%) of United States?
Ensure brevity in your answer.  -83.29. In the year 2004, what is the difference between the Net enrolment rate(%) of Ukraine and Net enrolment rate(%) of United States?
Make the answer very short. -2.09. In the year 2005, what is the difference between the Net enrolment rate(%) of Small states and Net enrolment rate(%) of Mozambique?
Offer a very short reply. 42.76. In the year 2005, what is the difference between the Net enrolment rate(%) of Small states and Net enrolment rate(%) of Ukraine?
Make the answer very short. -34.23. In the year 2005, what is the difference between the Net enrolment rate(%) in Small states and Net enrolment rate(%) in United States?
Provide a succinct answer. -37.12. In the year 2005, what is the difference between the Net enrolment rate(%) of Mozambique and Net enrolment rate(%) of Ukraine?
Give a very brief answer. -76.99. In the year 2005, what is the difference between the Net enrolment rate(%) in Mozambique and Net enrolment rate(%) in United States?
Provide a short and direct response. -79.88. In the year 2005, what is the difference between the Net enrolment rate(%) in Ukraine and Net enrolment rate(%) in United States?
Your answer should be very brief. -2.89. In the year 2006, what is the difference between the Net enrolment rate(%) in Small states and Net enrolment rate(%) in Mozambique?
Give a very brief answer. 41.01. In the year 2006, what is the difference between the Net enrolment rate(%) of Small states and Net enrolment rate(%) of Ukraine?
Offer a very short reply. -33. In the year 2006, what is the difference between the Net enrolment rate(%) of Small states and Net enrolment rate(%) of United States?
Offer a terse response. -36.94. In the year 2006, what is the difference between the Net enrolment rate(%) of Mozambique and Net enrolment rate(%) of Ukraine?
Offer a very short reply. -74.01. In the year 2006, what is the difference between the Net enrolment rate(%) of Mozambique and Net enrolment rate(%) of United States?
Keep it short and to the point. -77.95. In the year 2006, what is the difference between the Net enrolment rate(%) in Ukraine and Net enrolment rate(%) in United States?
Offer a very short reply. -3.94. In the year 2007, what is the difference between the Net enrolment rate(%) of Small states and Net enrolment rate(%) of Mozambique?
Your answer should be compact. 40.04. In the year 2007, what is the difference between the Net enrolment rate(%) in Small states and Net enrolment rate(%) in Ukraine?
Ensure brevity in your answer.  -32.85. In the year 2007, what is the difference between the Net enrolment rate(%) in Small states and Net enrolment rate(%) in United States?
Offer a very short reply. -36.45. In the year 2007, what is the difference between the Net enrolment rate(%) of Mozambique and Net enrolment rate(%) of Ukraine?
Give a very brief answer. -72.89. In the year 2007, what is the difference between the Net enrolment rate(%) in Mozambique and Net enrolment rate(%) in United States?
Your answer should be very brief. -76.5. In the year 2007, what is the difference between the Net enrolment rate(%) in Ukraine and Net enrolment rate(%) in United States?
Your answer should be very brief. -3.6. In the year 2008, what is the difference between the Net enrolment rate(%) in Small states and Net enrolment rate(%) in Mozambique?
Make the answer very short. 39.02. In the year 2008, what is the difference between the Net enrolment rate(%) in Small states and Net enrolment rate(%) in Ukraine?
Ensure brevity in your answer.  -32.57. In the year 2008, what is the difference between the Net enrolment rate(%) of Small states and Net enrolment rate(%) of United States?
Your answer should be compact. -36.24. In the year 2008, what is the difference between the Net enrolment rate(%) of Mozambique and Net enrolment rate(%) of Ukraine?
Keep it short and to the point. -71.59. In the year 2008, what is the difference between the Net enrolment rate(%) in Mozambique and Net enrolment rate(%) in United States?
Provide a short and direct response. -75.26. In the year 2008, what is the difference between the Net enrolment rate(%) in Ukraine and Net enrolment rate(%) in United States?
Provide a succinct answer. -3.67. In the year 2009, what is the difference between the Net enrolment rate(%) of Small states and Net enrolment rate(%) of Mozambique?
Provide a short and direct response. 37.11. In the year 2009, what is the difference between the Net enrolment rate(%) in Small states and Net enrolment rate(%) in Ukraine?
Offer a terse response. -32.11. In the year 2009, what is the difference between the Net enrolment rate(%) of Small states and Net enrolment rate(%) of United States?
Make the answer very short. -34.69. In the year 2009, what is the difference between the Net enrolment rate(%) of Mozambique and Net enrolment rate(%) of Ukraine?
Keep it short and to the point. -69.22. In the year 2009, what is the difference between the Net enrolment rate(%) of Mozambique and Net enrolment rate(%) of United States?
Provide a succinct answer. -71.8. In the year 2009, what is the difference between the Net enrolment rate(%) in Ukraine and Net enrolment rate(%) in United States?
Ensure brevity in your answer.  -2.58. In the year 2010, what is the difference between the Net enrolment rate(%) in Small states and Net enrolment rate(%) in Mozambique?
Your answer should be compact. 35.81. In the year 2010, what is the difference between the Net enrolment rate(%) of Small states and Net enrolment rate(%) of Ukraine?
Offer a terse response. -32.85. In the year 2010, what is the difference between the Net enrolment rate(%) of Small states and Net enrolment rate(%) of United States?
Ensure brevity in your answer.  -33.41. In the year 2010, what is the difference between the Net enrolment rate(%) in Mozambique and Net enrolment rate(%) in Ukraine?
Offer a very short reply. -68.66. In the year 2010, what is the difference between the Net enrolment rate(%) of Mozambique and Net enrolment rate(%) of United States?
Keep it short and to the point. -69.22. In the year 2010, what is the difference between the Net enrolment rate(%) in Ukraine and Net enrolment rate(%) in United States?
Make the answer very short. -0.56. What is the ratio of the Net enrolment rate(%) of Small states in 2002 to that in 2004?
Offer a very short reply. 0.95. What is the ratio of the Net enrolment rate(%) of Mozambique in 2002 to that in 2004?
Provide a succinct answer. 1.08. What is the ratio of the Net enrolment rate(%) in Ukraine in 2002 to that in 2004?
Your answer should be very brief. 1. What is the ratio of the Net enrolment rate(%) in United States in 2002 to that in 2004?
Your answer should be very brief. 0.96. What is the ratio of the Net enrolment rate(%) of Small states in 2002 to that in 2005?
Offer a very short reply. 0.94. What is the ratio of the Net enrolment rate(%) of Mozambique in 2002 to that in 2005?
Your response must be concise. 0.63. What is the ratio of the Net enrolment rate(%) of Ukraine in 2002 to that in 2005?
Offer a very short reply. 1.01. What is the ratio of the Net enrolment rate(%) of United States in 2002 to that in 2005?
Give a very brief answer. 0.97. What is the ratio of the Net enrolment rate(%) of Small states in 2002 to that in 2006?
Make the answer very short. 0.94. What is the ratio of the Net enrolment rate(%) in Mozambique in 2002 to that in 2006?
Provide a short and direct response. 0.51. What is the ratio of the Net enrolment rate(%) in Ukraine in 2002 to that in 2006?
Make the answer very short. 1.02. What is the ratio of the Net enrolment rate(%) in United States in 2002 to that in 2006?
Ensure brevity in your answer.  0.97. What is the ratio of the Net enrolment rate(%) of Small states in 2002 to that in 2007?
Offer a very short reply. 0.92. What is the ratio of the Net enrolment rate(%) of Mozambique in 2002 to that in 2007?
Your response must be concise. 0.43. What is the ratio of the Net enrolment rate(%) of Ukraine in 2002 to that in 2007?
Provide a short and direct response. 1.02. What is the ratio of the Net enrolment rate(%) in United States in 2002 to that in 2007?
Make the answer very short. 0.96. What is the ratio of the Net enrolment rate(%) of Small states in 2002 to that in 2008?
Ensure brevity in your answer.  0.91. What is the ratio of the Net enrolment rate(%) in Mozambique in 2002 to that in 2008?
Your answer should be compact. 0.38. What is the ratio of the Net enrolment rate(%) of Ukraine in 2002 to that in 2008?
Offer a terse response. 1.01. What is the ratio of the Net enrolment rate(%) of United States in 2002 to that in 2008?
Provide a succinct answer. 0.96. What is the ratio of the Net enrolment rate(%) in Small states in 2002 to that in 2009?
Your response must be concise. 0.9. What is the ratio of the Net enrolment rate(%) in Mozambique in 2002 to that in 2009?
Offer a very short reply. 0.32. What is the ratio of the Net enrolment rate(%) of Ukraine in 2002 to that in 2009?
Your response must be concise. 1.01. What is the ratio of the Net enrolment rate(%) in United States in 2002 to that in 2009?
Provide a succinct answer. 0.97. What is the ratio of the Net enrolment rate(%) in Small states in 2002 to that in 2010?
Make the answer very short. 0.9. What is the ratio of the Net enrolment rate(%) in Mozambique in 2002 to that in 2010?
Your response must be concise. 0.29. What is the ratio of the Net enrolment rate(%) of Ukraine in 2002 to that in 2010?
Keep it short and to the point. 1. What is the ratio of the Net enrolment rate(%) of United States in 2002 to that in 2010?
Give a very brief answer. 0.98. What is the ratio of the Net enrolment rate(%) in Small states in 2004 to that in 2005?
Offer a very short reply. 0.99. What is the ratio of the Net enrolment rate(%) in Mozambique in 2004 to that in 2005?
Give a very brief answer. 0.59. What is the ratio of the Net enrolment rate(%) in Ukraine in 2004 to that in 2005?
Make the answer very short. 1.01. What is the ratio of the Net enrolment rate(%) of Small states in 2004 to that in 2006?
Provide a succinct answer. 0.98. What is the ratio of the Net enrolment rate(%) in Mozambique in 2004 to that in 2006?
Keep it short and to the point. 0.47. What is the ratio of the Net enrolment rate(%) of Ukraine in 2004 to that in 2006?
Keep it short and to the point. 1.02. What is the ratio of the Net enrolment rate(%) of Small states in 2004 to that in 2007?
Give a very brief answer. 0.97. What is the ratio of the Net enrolment rate(%) of Mozambique in 2004 to that in 2007?
Provide a succinct answer. 0.4. What is the ratio of the Net enrolment rate(%) of Ukraine in 2004 to that in 2007?
Your answer should be compact. 1.02. What is the ratio of the Net enrolment rate(%) in Small states in 2004 to that in 2008?
Ensure brevity in your answer.  0.96. What is the ratio of the Net enrolment rate(%) in Mozambique in 2004 to that in 2008?
Offer a terse response. 0.35. What is the ratio of the Net enrolment rate(%) in Ukraine in 2004 to that in 2008?
Keep it short and to the point. 1.01. What is the ratio of the Net enrolment rate(%) of United States in 2004 to that in 2008?
Keep it short and to the point. 0.99. What is the ratio of the Net enrolment rate(%) of Small states in 2004 to that in 2009?
Keep it short and to the point. 0.95. What is the ratio of the Net enrolment rate(%) in Mozambique in 2004 to that in 2009?
Offer a very short reply. 0.29. What is the ratio of the Net enrolment rate(%) of Ukraine in 2004 to that in 2009?
Ensure brevity in your answer.  1.01. What is the ratio of the Net enrolment rate(%) of United States in 2004 to that in 2009?
Offer a terse response. 1.01. What is the ratio of the Net enrolment rate(%) in Small states in 2004 to that in 2010?
Your answer should be compact. 0.95. What is the ratio of the Net enrolment rate(%) in Mozambique in 2004 to that in 2010?
Make the answer very short. 0.27. What is the ratio of the Net enrolment rate(%) in Ukraine in 2004 to that in 2010?
Your answer should be compact. 1. What is the ratio of the Net enrolment rate(%) in United States in 2004 to that in 2010?
Make the answer very short. 1.02. What is the ratio of the Net enrolment rate(%) of Mozambique in 2005 to that in 2006?
Your answer should be compact. 0.8. What is the ratio of the Net enrolment rate(%) in Ukraine in 2005 to that in 2006?
Make the answer very short. 1.01. What is the ratio of the Net enrolment rate(%) of Small states in 2005 to that in 2007?
Your answer should be compact. 0.98. What is the ratio of the Net enrolment rate(%) of Mozambique in 2005 to that in 2007?
Your response must be concise. 0.68. What is the ratio of the Net enrolment rate(%) in Ukraine in 2005 to that in 2007?
Your answer should be compact. 1. What is the ratio of the Net enrolment rate(%) in United States in 2005 to that in 2007?
Provide a short and direct response. 1. What is the ratio of the Net enrolment rate(%) of Small states in 2005 to that in 2008?
Give a very brief answer. 0.97. What is the ratio of the Net enrolment rate(%) of Mozambique in 2005 to that in 2008?
Offer a terse response. 0.59. What is the ratio of the Net enrolment rate(%) of Ukraine in 2005 to that in 2008?
Give a very brief answer. 1. What is the ratio of the Net enrolment rate(%) in United States in 2005 to that in 2008?
Your answer should be compact. 0.99. What is the ratio of the Net enrolment rate(%) of Small states in 2005 to that in 2009?
Keep it short and to the point. 0.96. What is the ratio of the Net enrolment rate(%) in Mozambique in 2005 to that in 2009?
Ensure brevity in your answer.  0.5. What is the ratio of the Net enrolment rate(%) in Small states in 2005 to that in 2010?
Your answer should be compact. 0.96. What is the ratio of the Net enrolment rate(%) in Mozambique in 2005 to that in 2010?
Your response must be concise. 0.46. What is the ratio of the Net enrolment rate(%) in Ukraine in 2005 to that in 2010?
Offer a very short reply. 0.99. What is the ratio of the Net enrolment rate(%) of United States in 2005 to that in 2010?
Provide a short and direct response. 1.02. What is the ratio of the Net enrolment rate(%) in Small states in 2006 to that in 2007?
Provide a succinct answer. 0.98. What is the ratio of the Net enrolment rate(%) in Mozambique in 2006 to that in 2007?
Offer a terse response. 0.85. What is the ratio of the Net enrolment rate(%) in Ukraine in 2006 to that in 2007?
Give a very brief answer. 0.99. What is the ratio of the Net enrolment rate(%) in Small states in 2006 to that in 2008?
Your response must be concise. 0.97. What is the ratio of the Net enrolment rate(%) in Mozambique in 2006 to that in 2008?
Your answer should be very brief. 0.74. What is the ratio of the Net enrolment rate(%) of Ukraine in 2006 to that in 2008?
Ensure brevity in your answer.  0.99. What is the ratio of the Net enrolment rate(%) in United States in 2006 to that in 2008?
Make the answer very short. 0.99. What is the ratio of the Net enrolment rate(%) of Small states in 2006 to that in 2009?
Your answer should be very brief. 0.96. What is the ratio of the Net enrolment rate(%) of Mozambique in 2006 to that in 2009?
Your answer should be compact. 0.63. What is the ratio of the Net enrolment rate(%) of Ukraine in 2006 to that in 2009?
Provide a succinct answer. 0.99. What is the ratio of the Net enrolment rate(%) in United States in 2006 to that in 2009?
Make the answer very short. 1. What is the ratio of the Net enrolment rate(%) of Small states in 2006 to that in 2010?
Provide a short and direct response. 0.96. What is the ratio of the Net enrolment rate(%) of Mozambique in 2006 to that in 2010?
Your response must be concise. 0.57. What is the ratio of the Net enrolment rate(%) of Ukraine in 2006 to that in 2010?
Your answer should be compact. 0.98. What is the ratio of the Net enrolment rate(%) in United States in 2006 to that in 2010?
Provide a short and direct response. 1.02. What is the ratio of the Net enrolment rate(%) of Small states in 2007 to that in 2008?
Provide a succinct answer. 0.99. What is the ratio of the Net enrolment rate(%) of Mozambique in 2007 to that in 2008?
Provide a short and direct response. 0.87. What is the ratio of the Net enrolment rate(%) in Ukraine in 2007 to that in 2008?
Make the answer very short. 1. What is the ratio of the Net enrolment rate(%) in United States in 2007 to that in 2008?
Your answer should be very brief. 1. What is the ratio of the Net enrolment rate(%) of Small states in 2007 to that in 2009?
Provide a succinct answer. 0.98. What is the ratio of the Net enrolment rate(%) of Mozambique in 2007 to that in 2009?
Make the answer very short. 0.74. What is the ratio of the Net enrolment rate(%) of Ukraine in 2007 to that in 2009?
Your answer should be very brief. 1. What is the ratio of the Net enrolment rate(%) in Small states in 2007 to that in 2010?
Ensure brevity in your answer.  0.98. What is the ratio of the Net enrolment rate(%) of Mozambique in 2007 to that in 2010?
Give a very brief answer. 0.68. What is the ratio of the Net enrolment rate(%) of Ukraine in 2007 to that in 2010?
Your answer should be compact. 0.99. What is the ratio of the Net enrolment rate(%) in United States in 2007 to that in 2010?
Make the answer very short. 1.02. What is the ratio of the Net enrolment rate(%) of Mozambique in 2008 to that in 2009?
Your answer should be compact. 0.85. What is the ratio of the Net enrolment rate(%) in Ukraine in 2008 to that in 2009?
Provide a succinct answer. 1. What is the ratio of the Net enrolment rate(%) of United States in 2008 to that in 2009?
Your response must be concise. 1.01. What is the ratio of the Net enrolment rate(%) in Mozambique in 2008 to that in 2010?
Offer a terse response. 0.78. What is the ratio of the Net enrolment rate(%) of Ukraine in 2008 to that in 2010?
Offer a terse response. 0.99. What is the ratio of the Net enrolment rate(%) of Small states in 2009 to that in 2010?
Keep it short and to the point. 1. What is the ratio of the Net enrolment rate(%) of Mozambique in 2009 to that in 2010?
Your response must be concise. 0.92. What is the ratio of the Net enrolment rate(%) in United States in 2009 to that in 2010?
Offer a terse response. 1.01. What is the difference between the highest and the second highest Net enrolment rate(%) in Small states?
Ensure brevity in your answer.  0.14. What is the difference between the highest and the second highest Net enrolment rate(%) in Mozambique?
Keep it short and to the point. 1.44. What is the difference between the highest and the second highest Net enrolment rate(%) in Ukraine?
Give a very brief answer. 0.09. What is the difference between the highest and the second highest Net enrolment rate(%) of United States?
Offer a terse response. 0.42. What is the difference between the highest and the lowest Net enrolment rate(%) of Small states?
Your answer should be very brief. 5.15. What is the difference between the highest and the lowest Net enrolment rate(%) in Mozambique?
Keep it short and to the point. 12.36. What is the difference between the highest and the lowest Net enrolment rate(%) in Ukraine?
Your answer should be very brief. 2.04. What is the difference between the highest and the lowest Net enrolment rate(%) of United States?
Ensure brevity in your answer.  3.77. 